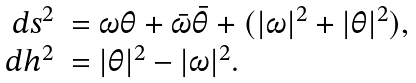Convert formula to latex. <formula><loc_0><loc_0><loc_500><loc_500>\begin{array} { r l } d s ^ { 2 } & = \omega \theta + \bar { \omega } \bar { \theta } + ( | \omega | ^ { 2 } + | \theta | ^ { 2 } ) , \\ d h ^ { 2 } & = | \theta | ^ { 2 } - | \omega | ^ { 2 } . \end{array}</formula> 